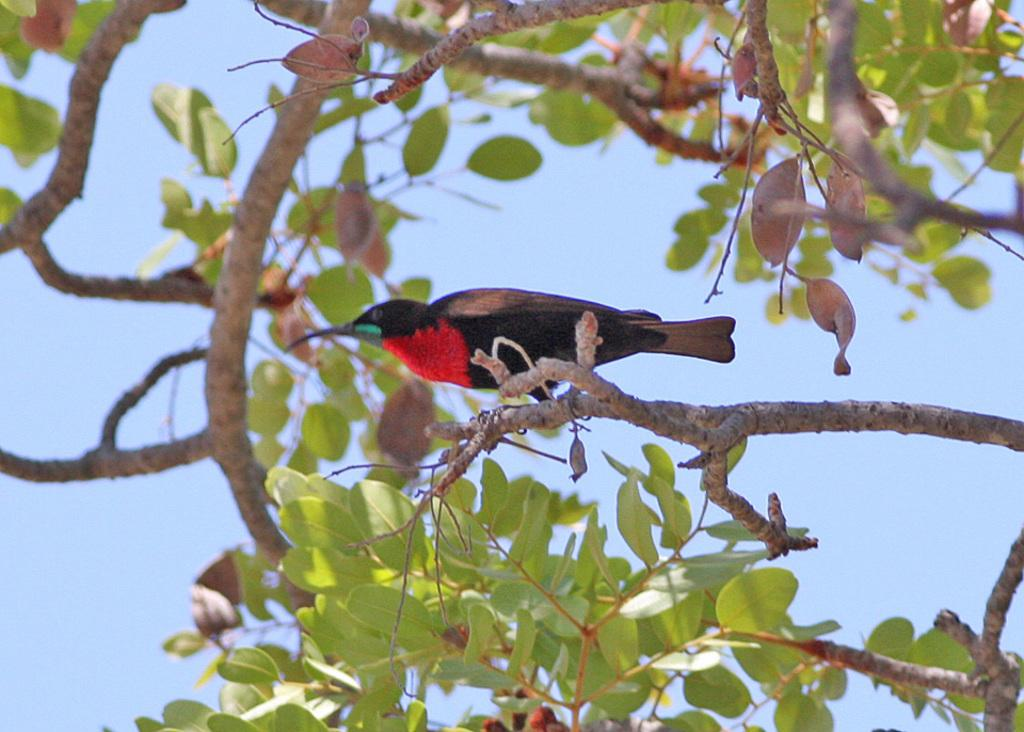What type of animal can be seen in the image? There is a bird in the image. Where is the bird located in the image? The bird is sitting on a tree. How many rings are the bird wearing on its legs in the image? There are no rings visible on the bird's legs in the image. What is the bird using to cover itself in the image? The bird is not using anything to cover itself in the image; it is sitting on a tree with its feathers exposed. 